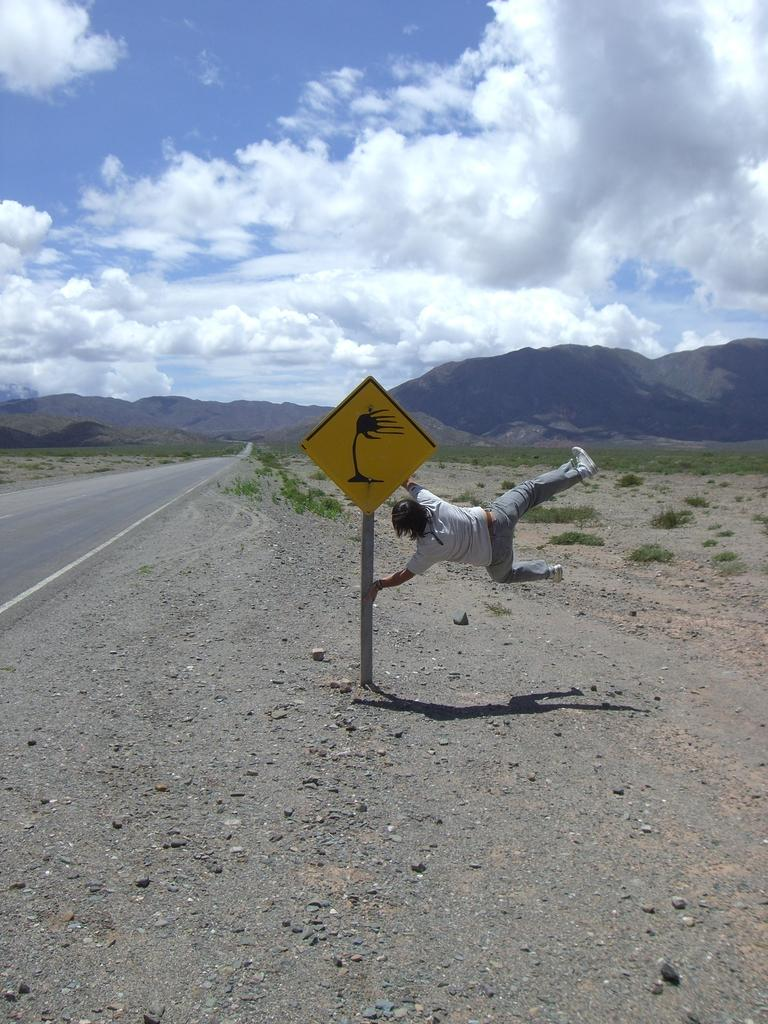What is the main object in the image? There is a sign board in the image. What is the man in the image holding? The man is holding a metal rod in the image. What can be seen in the background of the image? There are plants, hills, and clouds visible in the background of the image. What type of oatmeal is being served in the image? There is no oatmeal present in the image. What condition is the pail in, as seen in the image? There is no pail present in the image. 